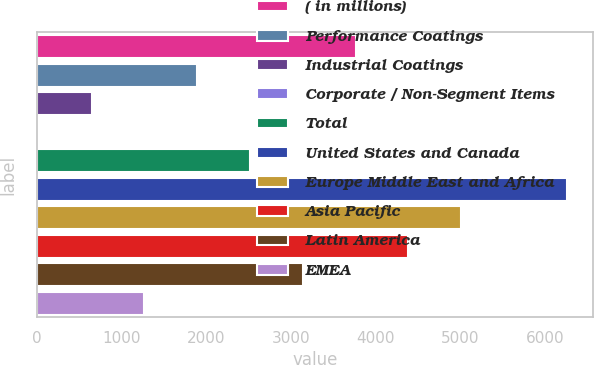<chart> <loc_0><loc_0><loc_500><loc_500><bar_chart><fcel>( in millions)<fcel>Performance Coatings<fcel>Industrial Coatings<fcel>Corporate / Non-Segment Items<fcel>Total<fcel>United States and Canada<fcel>Europe Middle East and Africa<fcel>Asia Pacific<fcel>Latin America<fcel>EMEA<nl><fcel>3762.4<fcel>1893.7<fcel>647.9<fcel>25<fcel>2516.6<fcel>6254<fcel>5008.2<fcel>4385.3<fcel>3139.5<fcel>1270.8<nl></chart> 